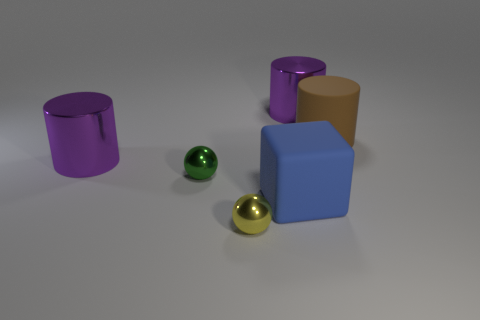Subtract all purple metal cylinders. How many cylinders are left? 1 Add 1 tiny spheres. How many objects exist? 7 Subtract all cyan balls. How many purple cylinders are left? 2 Subtract all cubes. How many objects are left? 5 Subtract 2 spheres. How many spheres are left? 0 Subtract all green spheres. How many spheres are left? 1 Subtract 1 brown cylinders. How many objects are left? 5 Subtract all red cylinders. Subtract all purple balls. How many cylinders are left? 3 Subtract all blue rubber cubes. Subtract all tiny yellow shiny objects. How many objects are left? 4 Add 2 big purple cylinders. How many big purple cylinders are left? 4 